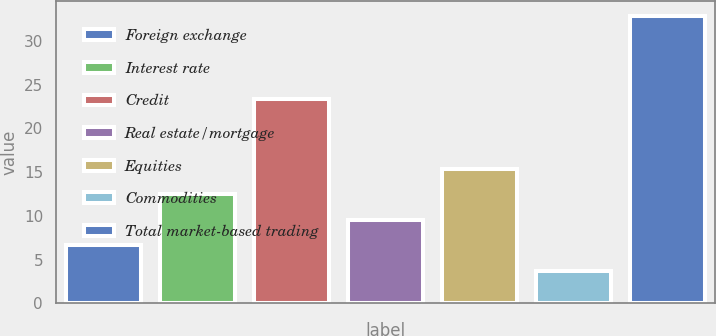<chart> <loc_0><loc_0><loc_500><loc_500><bar_chart><fcel>Foreign exchange<fcel>Interest rate<fcel>Credit<fcel>Real estate/mortgage<fcel>Equities<fcel>Commodities<fcel>Total market-based trading<nl><fcel>6.62<fcel>12.46<fcel>23.4<fcel>9.54<fcel>15.38<fcel>3.7<fcel>32.9<nl></chart> 